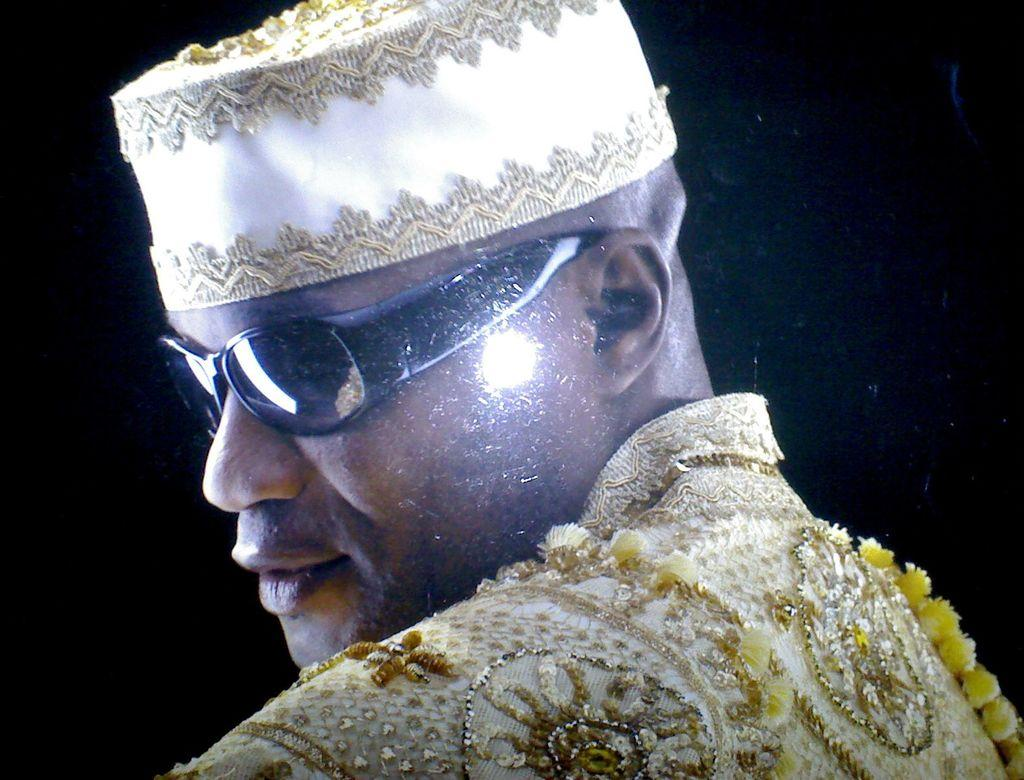Who is the main subject in the image? There is a man in the image. What is the man wearing? The man is wearing a yellow dress, goggles, and a cap. What can be observed about the background of the image? The background of the image is dark. What type of apple is being spread on the edge of the cap in the image? There is no apple present in the image, and the cap is not being used as a surface for spreading any substance. 